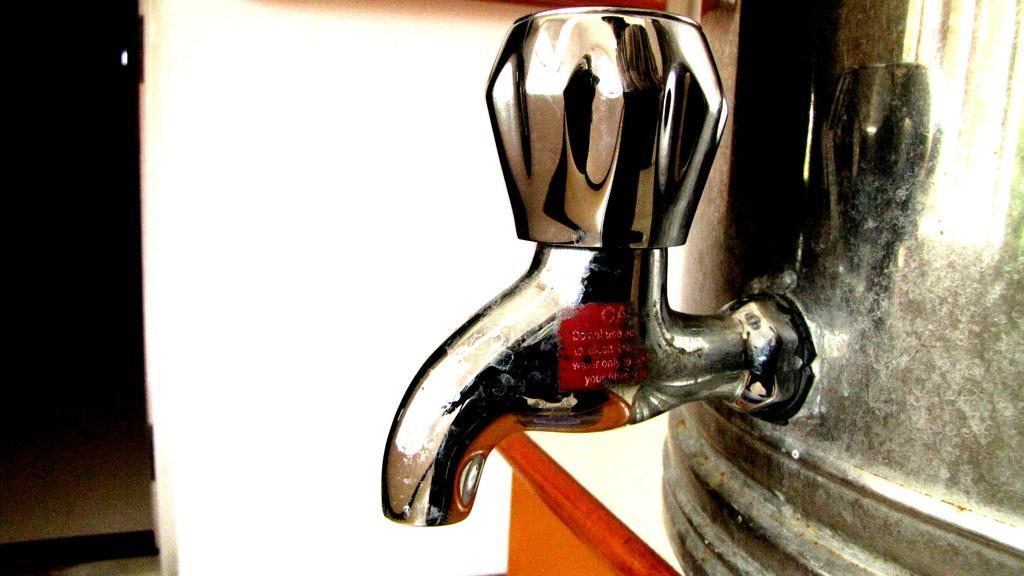Please provide a concise description of this image. In front of the picture, we see a tap. On the right side, we see a water filter which is placed on the white and the brown table. In the background, we see a white wall. In the left top, it is black in color. In the left bottom, we see a floor. 